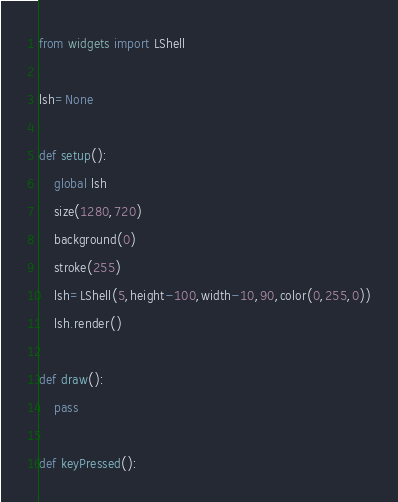Convert code to text. <code><loc_0><loc_0><loc_500><loc_500><_Python_>from widgets import LShell

lsh=None

def setup():
    global lsh
    size(1280,720)
    background(0)
    stroke(255)
    lsh=LShell(5,height-100,width-10,90,color(0,255,0))
    lsh.render()
    
def draw():
    pass

def keyPressed():</code> 